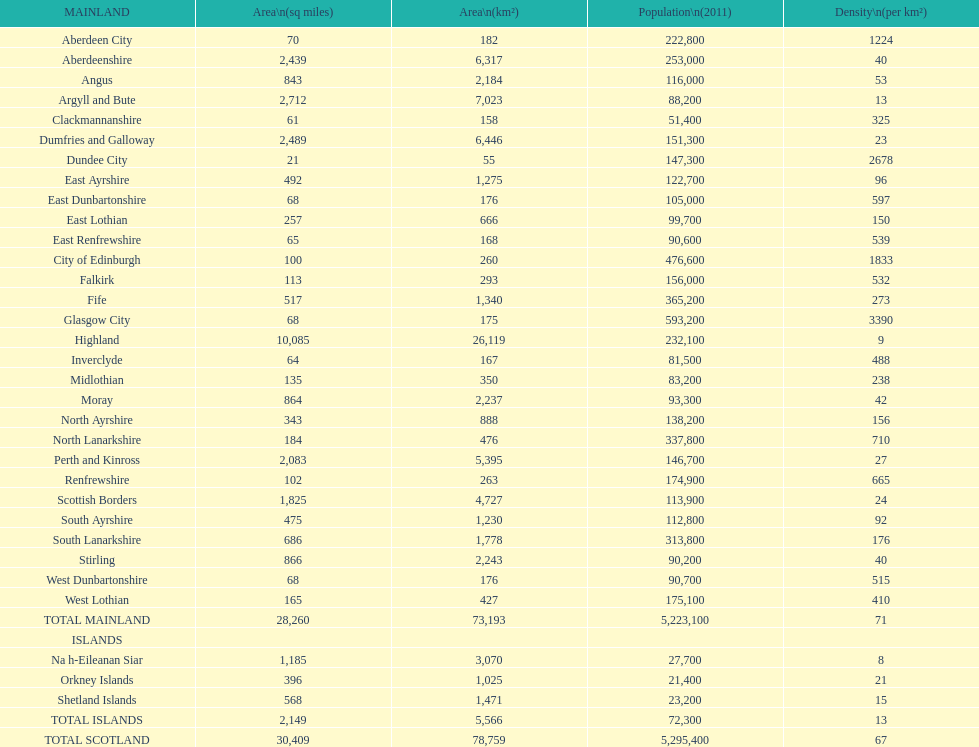What is the average population density in mainland cities? 71. 